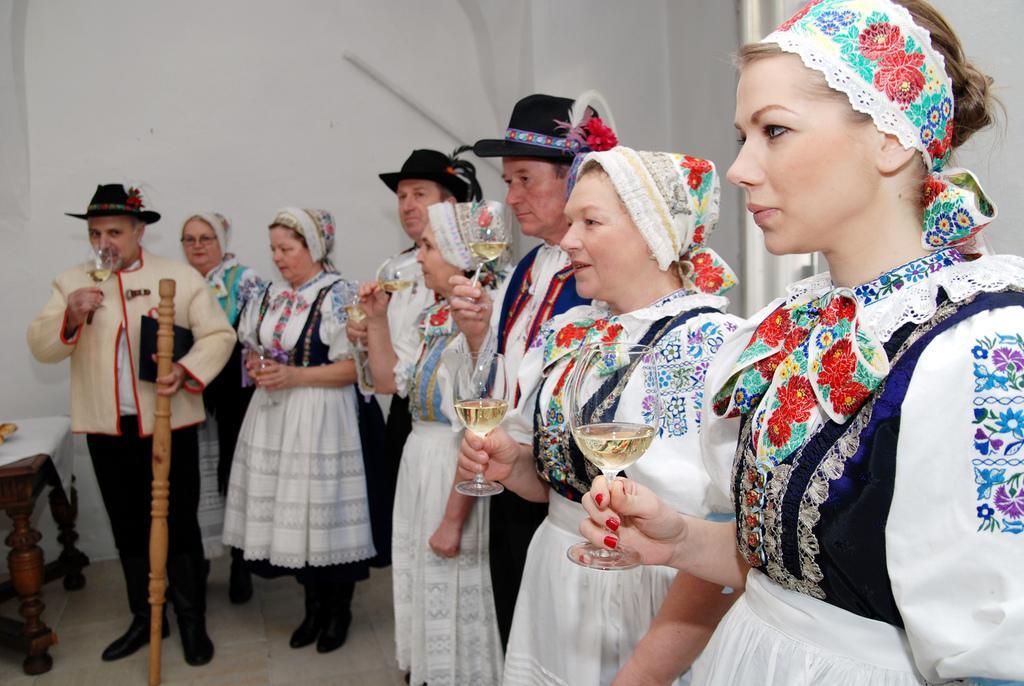How would you summarize this image in a sentence or two? There are people standing and holding glasses and this man holding a wooden object. We can see object and cloth on the table. In the background we can see wall. 